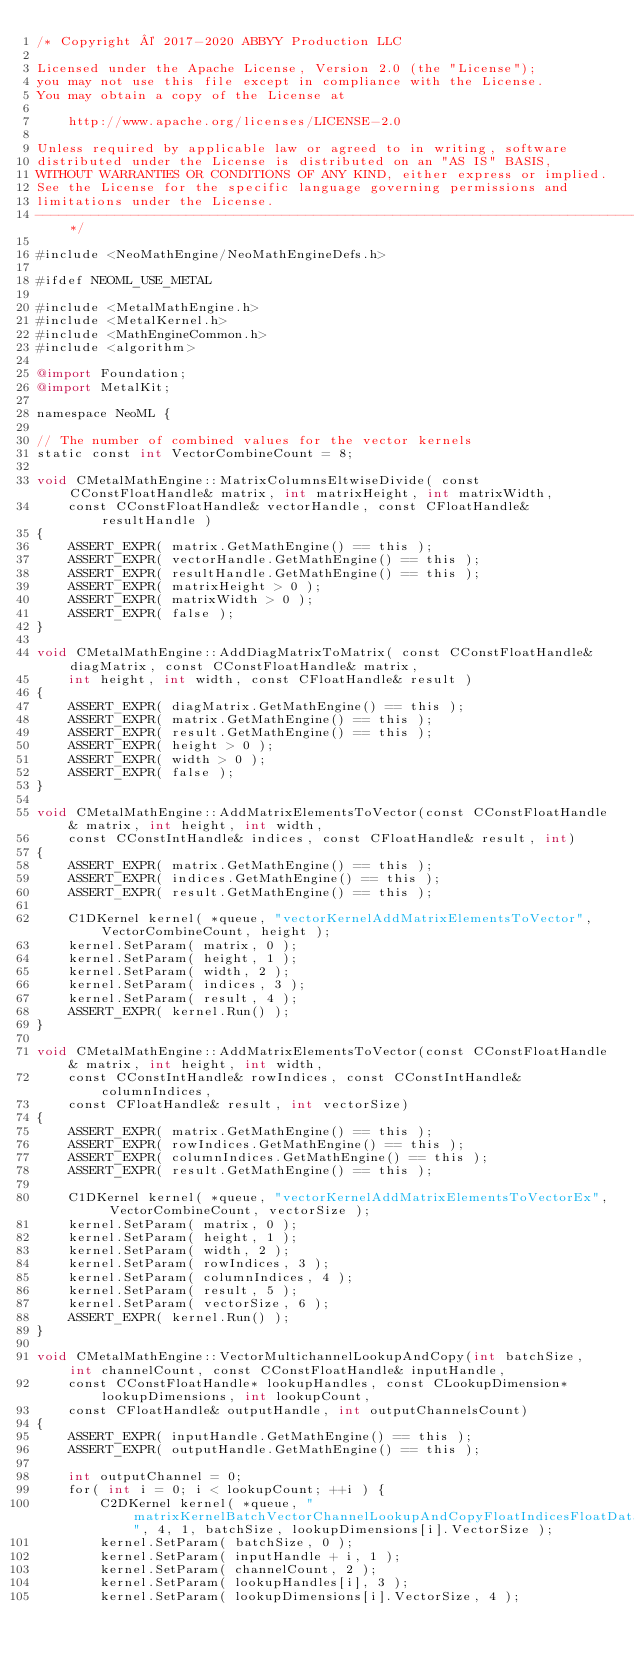Convert code to text. <code><loc_0><loc_0><loc_500><loc_500><_ObjectiveC_>/* Copyright © 2017-2020 ABBYY Production LLC

Licensed under the Apache License, Version 2.0 (the "License");
you may not use this file except in compliance with the License.
You may obtain a copy of the License at

	http://www.apache.org/licenses/LICENSE-2.0

Unless required by applicable law or agreed to in writing, software
distributed under the License is distributed on an "AS IS" BASIS,
WITHOUT WARRANTIES OR CONDITIONS OF ANY KIND, either express or implied.
See the License for the specific language governing permissions and
limitations under the License.
--------------------------------------------------------------------------------------------------------------*/

#include <NeoMathEngine/NeoMathEngineDefs.h>

#ifdef NEOML_USE_METAL

#include <MetalMathEngine.h>
#include <MetalKernel.h>
#include <MathEngineCommon.h>
#include <algorithm>

@import Foundation;
@import MetalKit;

namespace NeoML {
    
// The number of combined values for the vector kernels
static const int VectorCombineCount = 8;

void CMetalMathEngine::MatrixColumnsEltwiseDivide( const CConstFloatHandle& matrix, int matrixHeight, int matrixWidth,
	const CConstFloatHandle& vectorHandle, const CFloatHandle& resultHandle )
{
	ASSERT_EXPR( matrix.GetMathEngine() == this );
	ASSERT_EXPR( vectorHandle.GetMathEngine() == this );
	ASSERT_EXPR( resultHandle.GetMathEngine() == this );
	ASSERT_EXPR( matrixHeight > 0 );
	ASSERT_EXPR( matrixWidth > 0 );
	ASSERT_EXPR( false );
}

void CMetalMathEngine::AddDiagMatrixToMatrix( const CConstFloatHandle& diagMatrix, const CConstFloatHandle& matrix,
	int height, int width, const CFloatHandle& result )
{
	ASSERT_EXPR( diagMatrix.GetMathEngine() == this );
	ASSERT_EXPR( matrix.GetMathEngine() == this );
	ASSERT_EXPR( result.GetMathEngine() == this );
	ASSERT_EXPR( height > 0 );
	ASSERT_EXPR( width > 0 );
	ASSERT_EXPR( false );
}

void CMetalMathEngine::AddMatrixElementsToVector(const CConstFloatHandle& matrix, int height, int width,
	const CConstIntHandle& indices, const CFloatHandle& result, int)
{
    ASSERT_EXPR( matrix.GetMathEngine() == this );
	ASSERT_EXPR( indices.GetMathEngine() == this );
	ASSERT_EXPR( result.GetMathEngine() == this );

    C1DKernel kernel( *queue, "vectorKernelAddMatrixElementsToVector", VectorCombineCount, height );
    kernel.SetParam( matrix, 0 );
    kernel.SetParam( height, 1 );
    kernel.SetParam( width, 2 );
    kernel.SetParam( indices, 3 );
    kernel.SetParam( result, 4 );
    ASSERT_EXPR( kernel.Run() );
}

void CMetalMathEngine::AddMatrixElementsToVector(const CConstFloatHandle& matrix, int height, int width,
	const CConstIntHandle& rowIndices, const CConstIntHandle& columnIndices,
	const CFloatHandle& result, int vectorSize)
{
    ASSERT_EXPR( matrix.GetMathEngine() == this );
	ASSERT_EXPR( rowIndices.GetMathEngine() == this );
	ASSERT_EXPR( columnIndices.GetMathEngine() == this );
	ASSERT_EXPR( result.GetMathEngine() == this ); 

    C1DKernel kernel( *queue, "vectorKernelAddMatrixElementsToVectorEx", VectorCombineCount, vectorSize );
    kernel.SetParam( matrix, 0 );
    kernel.SetParam( height, 1 );
    kernel.SetParam( width, 2 );
    kernel.SetParam( rowIndices, 3 );
    kernel.SetParam( columnIndices, 4 );
    kernel.SetParam( result, 5 );
    kernel.SetParam( vectorSize, 6 );
    ASSERT_EXPR( kernel.Run() );
}

void CMetalMathEngine::VectorMultichannelLookupAndCopy(int batchSize, int channelCount, const CConstFloatHandle& inputHandle,
    const CConstFloatHandle* lookupHandles, const CLookupDimension* lookupDimensions, int lookupCount,
    const CFloatHandle& outputHandle, int outputChannelsCount)
{
    ASSERT_EXPR( inputHandle.GetMathEngine() == this );
	ASSERT_EXPR( outputHandle.GetMathEngine() == this );

    int outputChannel = 0;
    for( int i = 0; i < lookupCount; ++i ) {
        C2DKernel kernel( *queue, "matrixKernelBatchVectorChannelLookupAndCopyFloatIndicesFloatData", 4, 1, batchSize, lookupDimensions[i].VectorSize );
        kernel.SetParam( batchSize, 0 );
        kernel.SetParam( inputHandle + i, 1 );
        kernel.SetParam( channelCount, 2 );
        kernel.SetParam( lookupHandles[i], 3 );
        kernel.SetParam( lookupDimensions[i].VectorSize, 4 );</code> 